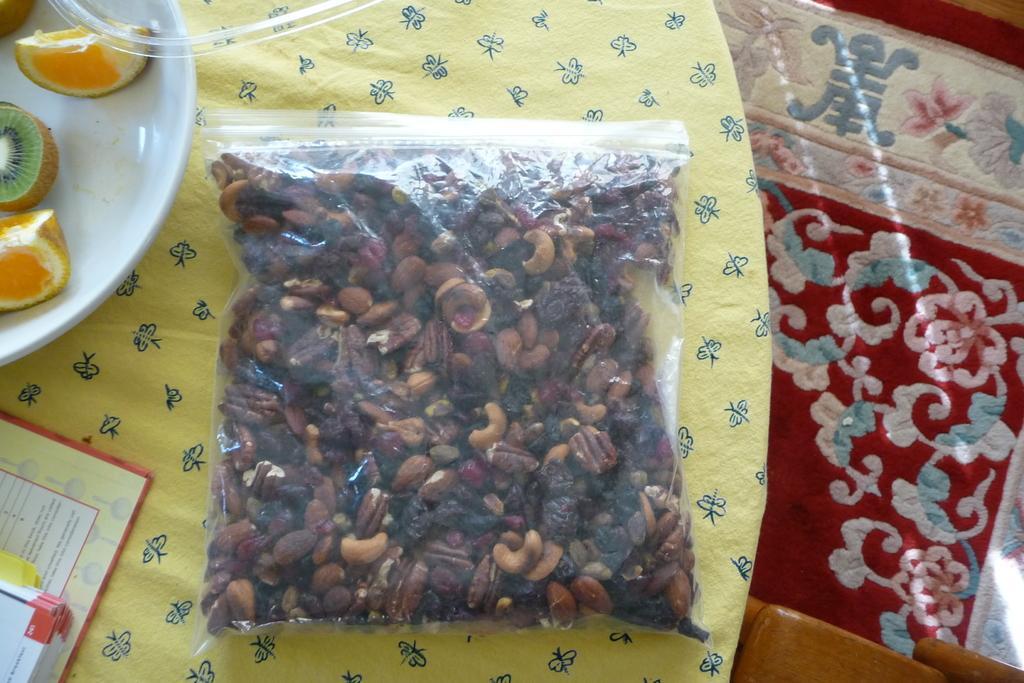How would you summarize this image in a sentence or two? In this image we can see a dry fruits packet and a plate of fruits placed on the table which is covered with the cloth. On the right, we can see a carpet on the floor. We can also see a wooden object and also the booklets. 